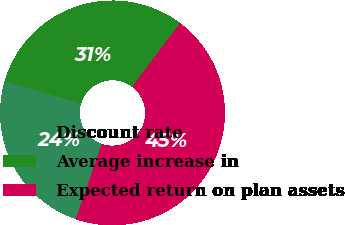Convert chart. <chart><loc_0><loc_0><loc_500><loc_500><pie_chart><fcel>Discount rate<fcel>Average increase in<fcel>Expected return on plan assets<nl><fcel>24.3%<fcel>30.71%<fcel>44.99%<nl></chart> 